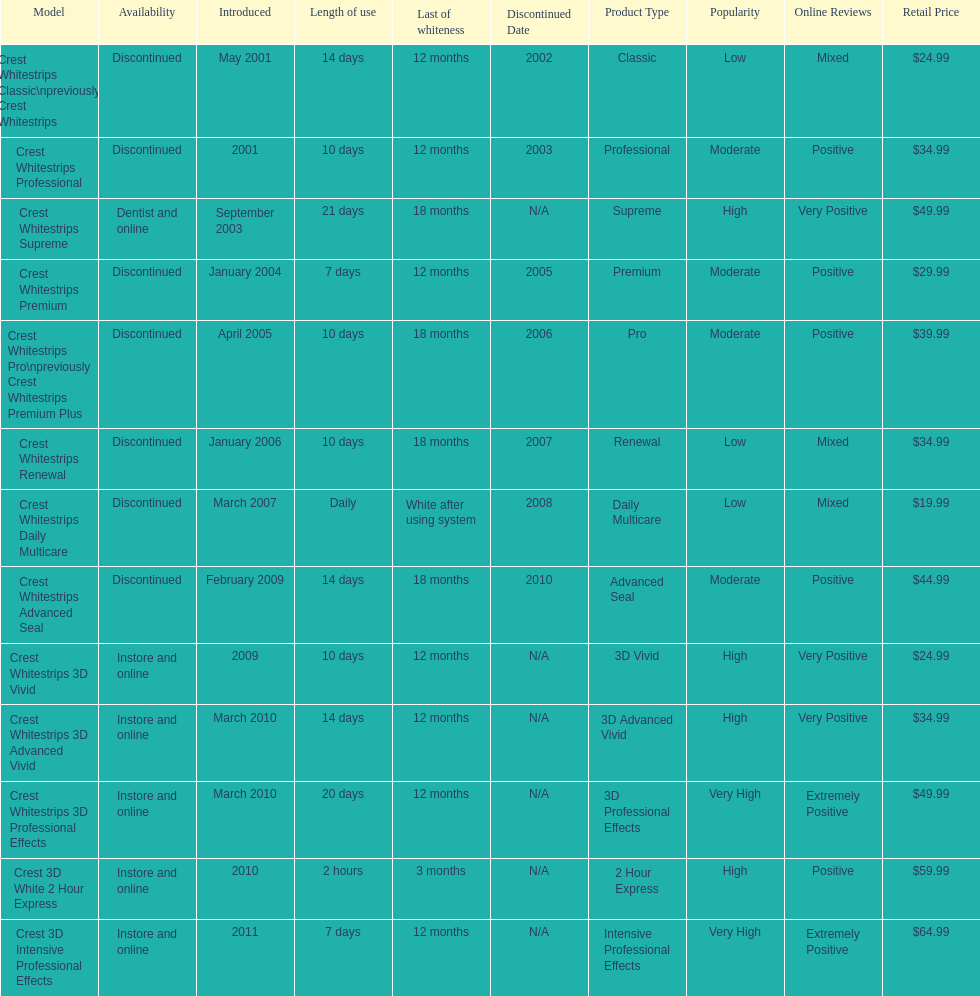Does the crest white strips pro last as long as the crest white strips renewal? Yes. 